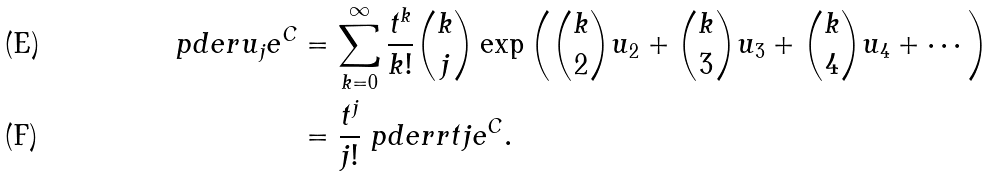Convert formula to latex. <formula><loc_0><loc_0><loc_500><loc_500>\ p d e r { u _ { j } } { e ^ { C } } & = \sum _ { k = 0 } ^ { \infty } \frac { t ^ { k } } { k ! } { \binom { k } { j } } \exp \left ( \binom { k } { 2 } u _ { 2 } + { \binom { k } { 3 } } u _ { 3 } + { \binom { k } { 4 } } u _ { 4 } + \cdots \right ) \\ & = \frac { t ^ { j } } { j ! } \ p d e r r t j { e ^ { C } } .</formula> 